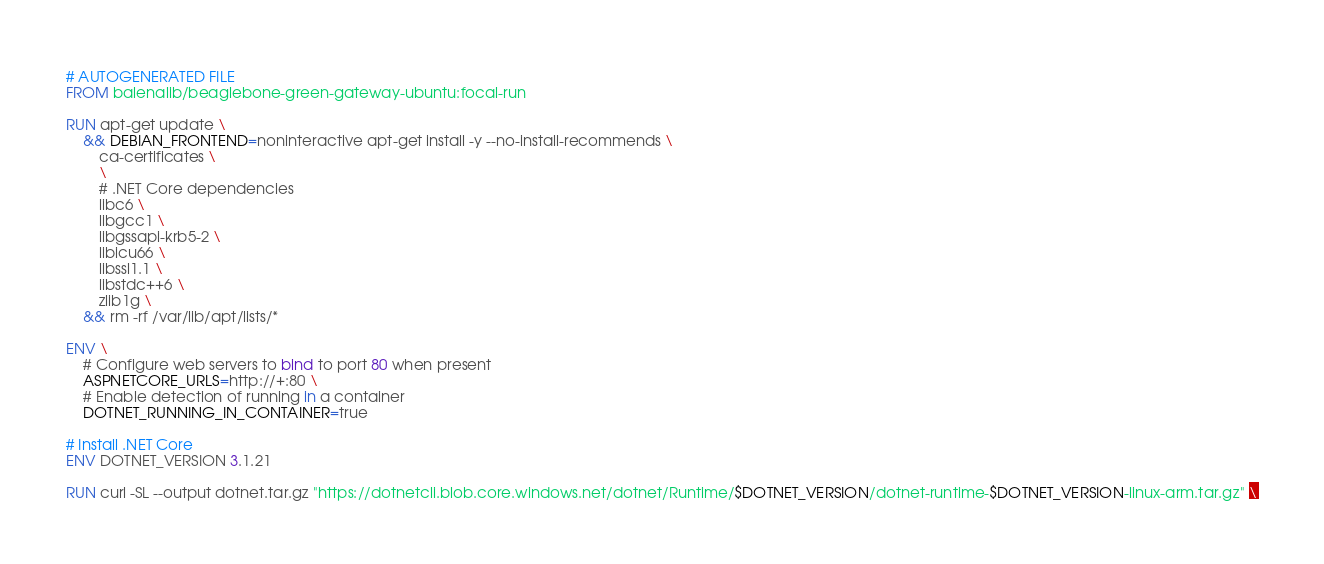Convert code to text. <code><loc_0><loc_0><loc_500><loc_500><_Dockerfile_># AUTOGENERATED FILE
FROM balenalib/beaglebone-green-gateway-ubuntu:focal-run

RUN apt-get update \
    && DEBIAN_FRONTEND=noninteractive apt-get install -y --no-install-recommends \
        ca-certificates \
        \
        # .NET Core dependencies
        libc6 \
        libgcc1 \
        libgssapi-krb5-2 \
        libicu66 \
        libssl1.1 \
        libstdc++6 \
        zlib1g \
    && rm -rf /var/lib/apt/lists/*

ENV \
    # Configure web servers to bind to port 80 when present
    ASPNETCORE_URLS=http://+:80 \
    # Enable detection of running in a container
    DOTNET_RUNNING_IN_CONTAINER=true

# Install .NET Core
ENV DOTNET_VERSION 3.1.21

RUN curl -SL --output dotnet.tar.gz "https://dotnetcli.blob.core.windows.net/dotnet/Runtime/$DOTNET_VERSION/dotnet-runtime-$DOTNET_VERSION-linux-arm.tar.gz" \</code> 